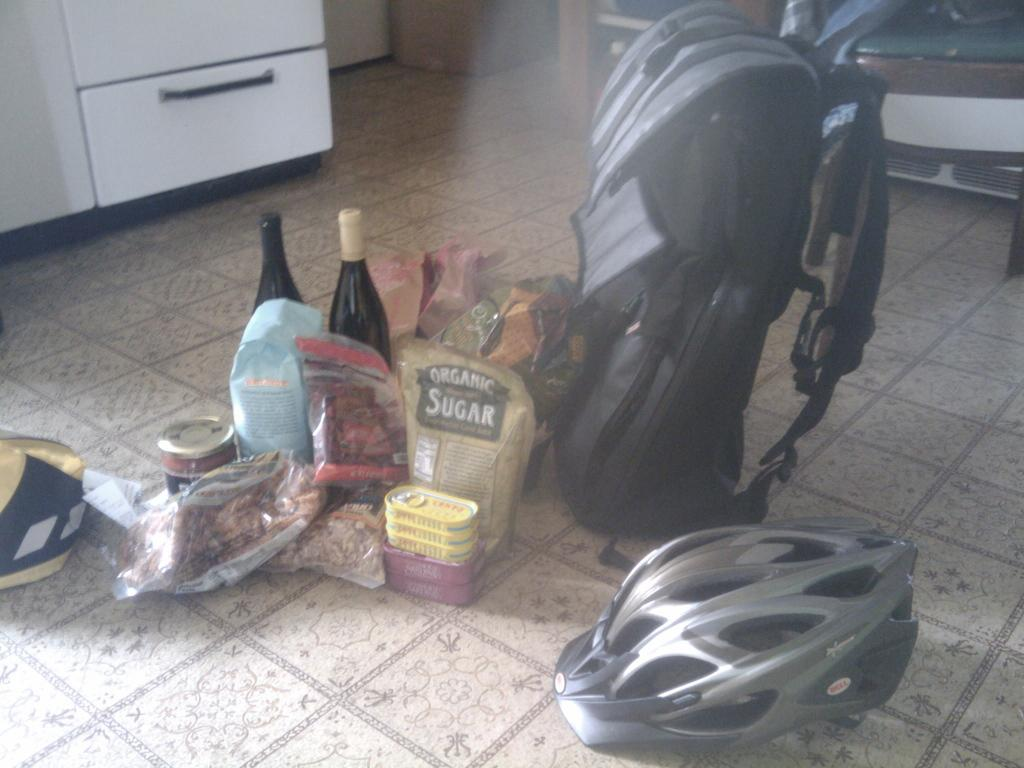What can be seen in the background of the image? There are objects in the background of the image. What type of containers are visible in the image? There are bottles in the image. What protective gear is present in the image? There is a helmet in the image. What type of bag is visible in the image? There is a backpack in the image. What type of container is present on a surface in the image? There is a jar in the image. What is on the floor in the image? There are objects on the floor in the image. What type of volcano is erupting in the image? There is no volcano present in the image. What decision is the manager making in the image? There is no manager or decision-making process depicted in the image. 